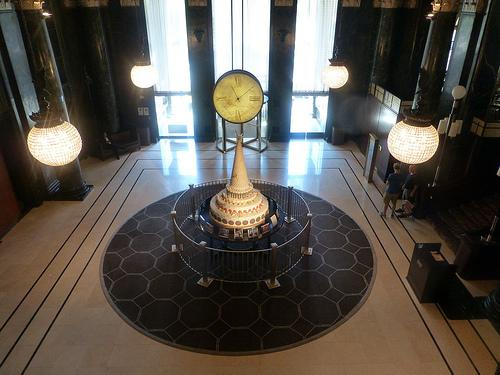Question: where is this taken?
Choices:
A. Lobby.
B. Mountain.
C. In a rotunda.
D. At school.
Answer with the letter. Answer: C Question: how many hanging lights are on?
Choices:
A. Three.
B. Four.
C. None.
D. One.
Answer with the letter. Answer: B Question: how many people are here?
Choices:
A. Three.
B. Two.
C. One.
D. Four.
Answer with the letter. Answer: A Question: what shape is the fencing on the floor?
Choices:
A. Square.
B. Circle.
C. Rectangle.
D. Diamond.
Answer with the letter. Answer: B Question: what shape are the hanging lights?
Choices:
A. Elipses.
B. Cubes.
C. Spheres.
D. Cones.
Answer with the letter. Answer: C 